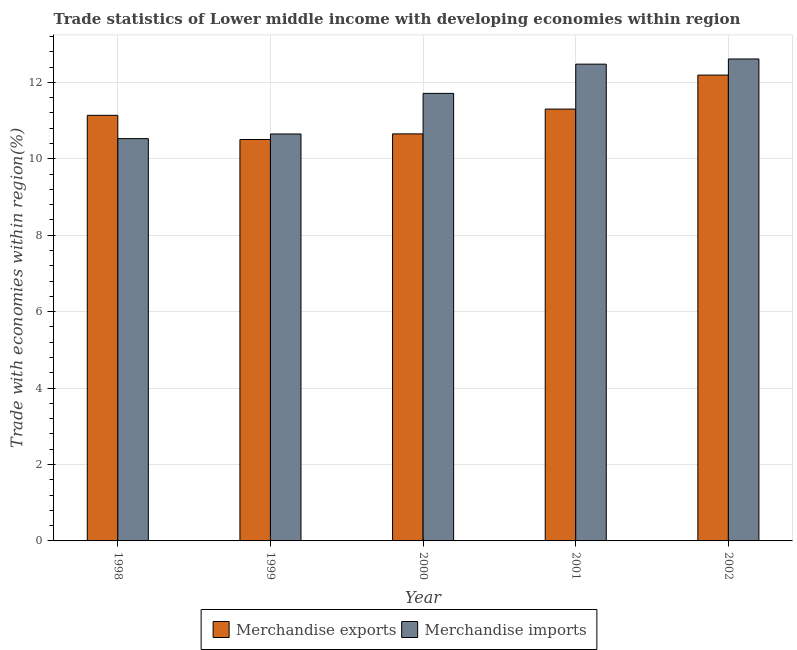Are the number of bars on each tick of the X-axis equal?
Your answer should be compact. Yes. What is the label of the 5th group of bars from the left?
Your answer should be compact. 2002. In how many cases, is the number of bars for a given year not equal to the number of legend labels?
Your response must be concise. 0. What is the merchandise imports in 2000?
Provide a succinct answer. 11.71. Across all years, what is the maximum merchandise exports?
Provide a succinct answer. 12.19. Across all years, what is the minimum merchandise imports?
Your answer should be compact. 10.53. What is the total merchandise imports in the graph?
Your response must be concise. 57.98. What is the difference between the merchandise exports in 1999 and that in 2002?
Your answer should be very brief. -1.69. What is the difference between the merchandise imports in 2001 and the merchandise exports in 2002?
Provide a short and direct response. -0.14. What is the average merchandise exports per year?
Make the answer very short. 11.16. In the year 1998, what is the difference between the merchandise imports and merchandise exports?
Give a very brief answer. 0. What is the ratio of the merchandise exports in 1998 to that in 1999?
Ensure brevity in your answer.  1.06. Is the merchandise exports in 1998 less than that in 1999?
Give a very brief answer. No. What is the difference between the highest and the second highest merchandise imports?
Keep it short and to the point. 0.14. What is the difference between the highest and the lowest merchandise exports?
Make the answer very short. 1.69. Is the sum of the merchandise exports in 1998 and 2000 greater than the maximum merchandise imports across all years?
Provide a short and direct response. Yes. How many bars are there?
Keep it short and to the point. 10. Does the graph contain grids?
Provide a succinct answer. Yes. Where does the legend appear in the graph?
Provide a succinct answer. Bottom center. How are the legend labels stacked?
Your answer should be very brief. Horizontal. What is the title of the graph?
Your answer should be very brief. Trade statistics of Lower middle income with developing economies within region. What is the label or title of the X-axis?
Ensure brevity in your answer.  Year. What is the label or title of the Y-axis?
Your answer should be very brief. Trade with economies within region(%). What is the Trade with economies within region(%) in Merchandise exports in 1998?
Keep it short and to the point. 11.14. What is the Trade with economies within region(%) of Merchandise imports in 1998?
Give a very brief answer. 10.53. What is the Trade with economies within region(%) in Merchandise exports in 1999?
Offer a terse response. 10.51. What is the Trade with economies within region(%) in Merchandise imports in 1999?
Make the answer very short. 10.65. What is the Trade with economies within region(%) in Merchandise exports in 2000?
Make the answer very short. 10.65. What is the Trade with economies within region(%) of Merchandise imports in 2000?
Your answer should be compact. 11.71. What is the Trade with economies within region(%) of Merchandise exports in 2001?
Your answer should be very brief. 11.3. What is the Trade with economies within region(%) in Merchandise imports in 2001?
Ensure brevity in your answer.  12.48. What is the Trade with economies within region(%) of Merchandise exports in 2002?
Ensure brevity in your answer.  12.19. What is the Trade with economies within region(%) of Merchandise imports in 2002?
Make the answer very short. 12.61. Across all years, what is the maximum Trade with economies within region(%) of Merchandise exports?
Provide a succinct answer. 12.19. Across all years, what is the maximum Trade with economies within region(%) in Merchandise imports?
Ensure brevity in your answer.  12.61. Across all years, what is the minimum Trade with economies within region(%) in Merchandise exports?
Ensure brevity in your answer.  10.51. Across all years, what is the minimum Trade with economies within region(%) of Merchandise imports?
Provide a succinct answer. 10.53. What is the total Trade with economies within region(%) of Merchandise exports in the graph?
Ensure brevity in your answer.  55.79. What is the total Trade with economies within region(%) in Merchandise imports in the graph?
Your response must be concise. 57.98. What is the difference between the Trade with economies within region(%) in Merchandise exports in 1998 and that in 1999?
Provide a succinct answer. 0.63. What is the difference between the Trade with economies within region(%) of Merchandise imports in 1998 and that in 1999?
Give a very brief answer. -0.12. What is the difference between the Trade with economies within region(%) of Merchandise exports in 1998 and that in 2000?
Offer a very short reply. 0.49. What is the difference between the Trade with economies within region(%) in Merchandise imports in 1998 and that in 2000?
Make the answer very short. -1.18. What is the difference between the Trade with economies within region(%) in Merchandise exports in 1998 and that in 2001?
Your answer should be compact. -0.16. What is the difference between the Trade with economies within region(%) of Merchandise imports in 1998 and that in 2001?
Your response must be concise. -1.95. What is the difference between the Trade with economies within region(%) in Merchandise exports in 1998 and that in 2002?
Your response must be concise. -1.05. What is the difference between the Trade with economies within region(%) in Merchandise imports in 1998 and that in 2002?
Your answer should be very brief. -2.08. What is the difference between the Trade with economies within region(%) in Merchandise exports in 1999 and that in 2000?
Offer a very short reply. -0.15. What is the difference between the Trade with economies within region(%) of Merchandise imports in 1999 and that in 2000?
Give a very brief answer. -1.06. What is the difference between the Trade with economies within region(%) of Merchandise exports in 1999 and that in 2001?
Your answer should be compact. -0.8. What is the difference between the Trade with economies within region(%) of Merchandise imports in 1999 and that in 2001?
Your response must be concise. -1.83. What is the difference between the Trade with economies within region(%) in Merchandise exports in 1999 and that in 2002?
Offer a terse response. -1.69. What is the difference between the Trade with economies within region(%) in Merchandise imports in 1999 and that in 2002?
Offer a terse response. -1.96. What is the difference between the Trade with economies within region(%) of Merchandise exports in 2000 and that in 2001?
Offer a very short reply. -0.65. What is the difference between the Trade with economies within region(%) of Merchandise imports in 2000 and that in 2001?
Your answer should be very brief. -0.77. What is the difference between the Trade with economies within region(%) of Merchandise exports in 2000 and that in 2002?
Your response must be concise. -1.54. What is the difference between the Trade with economies within region(%) of Merchandise imports in 2000 and that in 2002?
Your answer should be very brief. -0.9. What is the difference between the Trade with economies within region(%) of Merchandise exports in 2001 and that in 2002?
Give a very brief answer. -0.89. What is the difference between the Trade with economies within region(%) of Merchandise imports in 2001 and that in 2002?
Offer a very short reply. -0.14. What is the difference between the Trade with economies within region(%) of Merchandise exports in 1998 and the Trade with economies within region(%) of Merchandise imports in 1999?
Offer a very short reply. 0.49. What is the difference between the Trade with economies within region(%) in Merchandise exports in 1998 and the Trade with economies within region(%) in Merchandise imports in 2000?
Provide a succinct answer. -0.57. What is the difference between the Trade with economies within region(%) in Merchandise exports in 1998 and the Trade with economies within region(%) in Merchandise imports in 2001?
Keep it short and to the point. -1.34. What is the difference between the Trade with economies within region(%) in Merchandise exports in 1998 and the Trade with economies within region(%) in Merchandise imports in 2002?
Your answer should be very brief. -1.48. What is the difference between the Trade with economies within region(%) in Merchandise exports in 1999 and the Trade with economies within region(%) in Merchandise imports in 2000?
Make the answer very short. -1.21. What is the difference between the Trade with economies within region(%) of Merchandise exports in 1999 and the Trade with economies within region(%) of Merchandise imports in 2001?
Your answer should be compact. -1.97. What is the difference between the Trade with economies within region(%) of Merchandise exports in 1999 and the Trade with economies within region(%) of Merchandise imports in 2002?
Your answer should be very brief. -2.11. What is the difference between the Trade with economies within region(%) in Merchandise exports in 2000 and the Trade with economies within region(%) in Merchandise imports in 2001?
Keep it short and to the point. -1.83. What is the difference between the Trade with economies within region(%) in Merchandise exports in 2000 and the Trade with economies within region(%) in Merchandise imports in 2002?
Give a very brief answer. -1.96. What is the difference between the Trade with economies within region(%) in Merchandise exports in 2001 and the Trade with economies within region(%) in Merchandise imports in 2002?
Provide a short and direct response. -1.31. What is the average Trade with economies within region(%) of Merchandise exports per year?
Your response must be concise. 11.16. What is the average Trade with economies within region(%) of Merchandise imports per year?
Offer a terse response. 11.6. In the year 1998, what is the difference between the Trade with economies within region(%) of Merchandise exports and Trade with economies within region(%) of Merchandise imports?
Provide a short and direct response. 0.61. In the year 1999, what is the difference between the Trade with economies within region(%) of Merchandise exports and Trade with economies within region(%) of Merchandise imports?
Provide a succinct answer. -0.14. In the year 2000, what is the difference between the Trade with economies within region(%) of Merchandise exports and Trade with economies within region(%) of Merchandise imports?
Keep it short and to the point. -1.06. In the year 2001, what is the difference between the Trade with economies within region(%) in Merchandise exports and Trade with economies within region(%) in Merchandise imports?
Offer a very short reply. -1.18. In the year 2002, what is the difference between the Trade with economies within region(%) of Merchandise exports and Trade with economies within region(%) of Merchandise imports?
Give a very brief answer. -0.42. What is the ratio of the Trade with economies within region(%) of Merchandise exports in 1998 to that in 1999?
Keep it short and to the point. 1.06. What is the ratio of the Trade with economies within region(%) in Merchandise imports in 1998 to that in 1999?
Offer a terse response. 0.99. What is the ratio of the Trade with economies within region(%) in Merchandise exports in 1998 to that in 2000?
Ensure brevity in your answer.  1.05. What is the ratio of the Trade with economies within region(%) in Merchandise imports in 1998 to that in 2000?
Offer a very short reply. 0.9. What is the ratio of the Trade with economies within region(%) in Merchandise exports in 1998 to that in 2001?
Keep it short and to the point. 0.99. What is the ratio of the Trade with economies within region(%) in Merchandise imports in 1998 to that in 2001?
Provide a succinct answer. 0.84. What is the ratio of the Trade with economies within region(%) of Merchandise exports in 1998 to that in 2002?
Your response must be concise. 0.91. What is the ratio of the Trade with economies within region(%) in Merchandise imports in 1998 to that in 2002?
Your answer should be compact. 0.83. What is the ratio of the Trade with economies within region(%) of Merchandise exports in 1999 to that in 2000?
Make the answer very short. 0.99. What is the ratio of the Trade with economies within region(%) of Merchandise imports in 1999 to that in 2000?
Your answer should be very brief. 0.91. What is the ratio of the Trade with economies within region(%) in Merchandise exports in 1999 to that in 2001?
Your answer should be compact. 0.93. What is the ratio of the Trade with economies within region(%) of Merchandise imports in 1999 to that in 2001?
Offer a very short reply. 0.85. What is the ratio of the Trade with economies within region(%) in Merchandise exports in 1999 to that in 2002?
Make the answer very short. 0.86. What is the ratio of the Trade with economies within region(%) of Merchandise imports in 1999 to that in 2002?
Offer a very short reply. 0.84. What is the ratio of the Trade with economies within region(%) of Merchandise exports in 2000 to that in 2001?
Your answer should be very brief. 0.94. What is the ratio of the Trade with economies within region(%) in Merchandise imports in 2000 to that in 2001?
Ensure brevity in your answer.  0.94. What is the ratio of the Trade with economies within region(%) of Merchandise exports in 2000 to that in 2002?
Give a very brief answer. 0.87. What is the ratio of the Trade with economies within region(%) in Merchandise exports in 2001 to that in 2002?
Offer a terse response. 0.93. What is the ratio of the Trade with economies within region(%) of Merchandise imports in 2001 to that in 2002?
Your answer should be very brief. 0.99. What is the difference between the highest and the second highest Trade with economies within region(%) of Merchandise exports?
Keep it short and to the point. 0.89. What is the difference between the highest and the second highest Trade with economies within region(%) of Merchandise imports?
Your response must be concise. 0.14. What is the difference between the highest and the lowest Trade with economies within region(%) of Merchandise exports?
Keep it short and to the point. 1.69. What is the difference between the highest and the lowest Trade with economies within region(%) in Merchandise imports?
Make the answer very short. 2.08. 